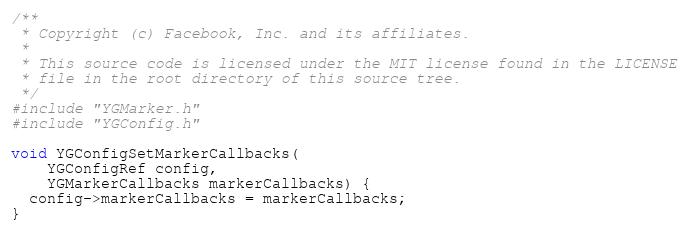<code> <loc_0><loc_0><loc_500><loc_500><_C++_>/**
 * Copyright (c) Facebook, Inc. and its affiliates.
 *
 * This source code is licensed under the MIT license found in the LICENSE
 * file in the root directory of this source tree.
 */
#include "YGMarker.h"
#include "YGConfig.h"

void YGConfigSetMarkerCallbacks(
    YGConfigRef config,
    YGMarkerCallbacks markerCallbacks) {
  config->markerCallbacks = markerCallbacks;
}
</code> 